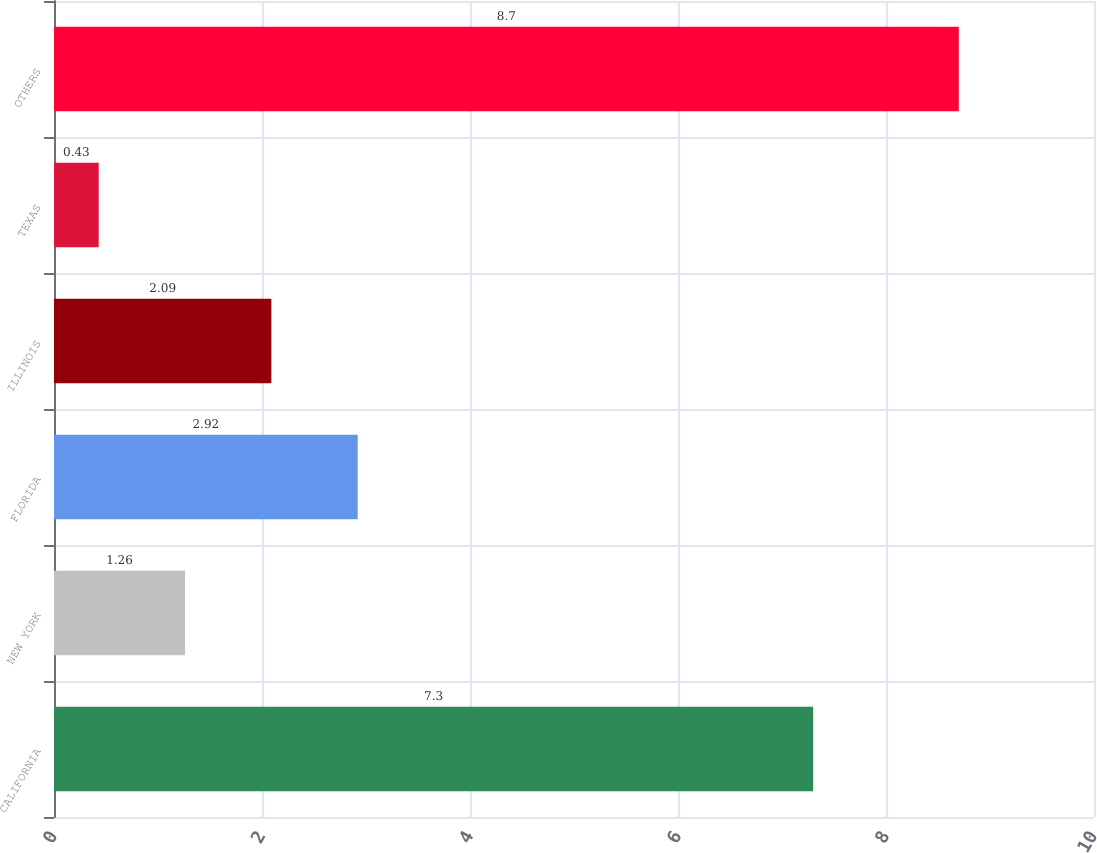Convert chart. <chart><loc_0><loc_0><loc_500><loc_500><bar_chart><fcel>CALIFORNIA<fcel>NEW YORK<fcel>FLORIDA<fcel>ILLINOIS<fcel>TEXAS<fcel>OTHERS<nl><fcel>7.3<fcel>1.26<fcel>2.92<fcel>2.09<fcel>0.43<fcel>8.7<nl></chart> 